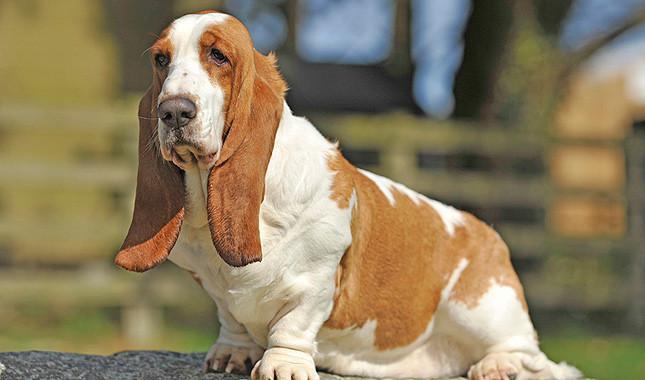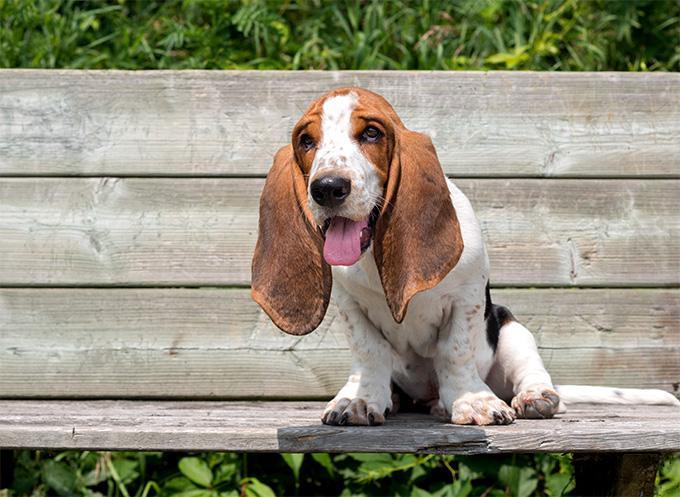The first image is the image on the left, the second image is the image on the right. Considering the images on both sides, is "In one of the images there is a basset hound puppy sitting." valid? Answer yes or no. Yes. 